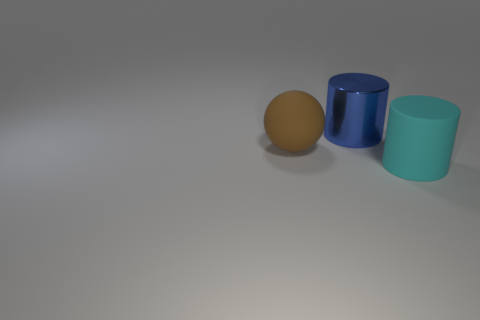Subtract all gray cylinders. Subtract all green cubes. How many cylinders are left? 2 Subtract all green spheres. How many brown cylinders are left? 0 Add 1 cyans. How many things exist? 0 Subtract all yellow metallic blocks. Subtract all matte balls. How many objects are left? 2 Add 2 balls. How many balls are left? 3 Add 3 tiny brown shiny things. How many tiny brown shiny things exist? 3 Add 2 large cubes. How many objects exist? 5 Subtract all cyan cylinders. How many cylinders are left? 1 Subtract 0 red cubes. How many objects are left? 3 Subtract all cylinders. How many objects are left? 1 